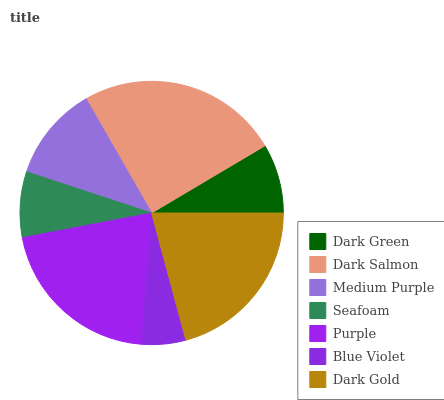Is Blue Violet the minimum?
Answer yes or no. Yes. Is Dark Salmon the maximum?
Answer yes or no. Yes. Is Medium Purple the minimum?
Answer yes or no. No. Is Medium Purple the maximum?
Answer yes or no. No. Is Dark Salmon greater than Medium Purple?
Answer yes or no. Yes. Is Medium Purple less than Dark Salmon?
Answer yes or no. Yes. Is Medium Purple greater than Dark Salmon?
Answer yes or no. No. Is Dark Salmon less than Medium Purple?
Answer yes or no. No. Is Medium Purple the high median?
Answer yes or no. Yes. Is Medium Purple the low median?
Answer yes or no. Yes. Is Dark Salmon the high median?
Answer yes or no. No. Is Purple the low median?
Answer yes or no. No. 